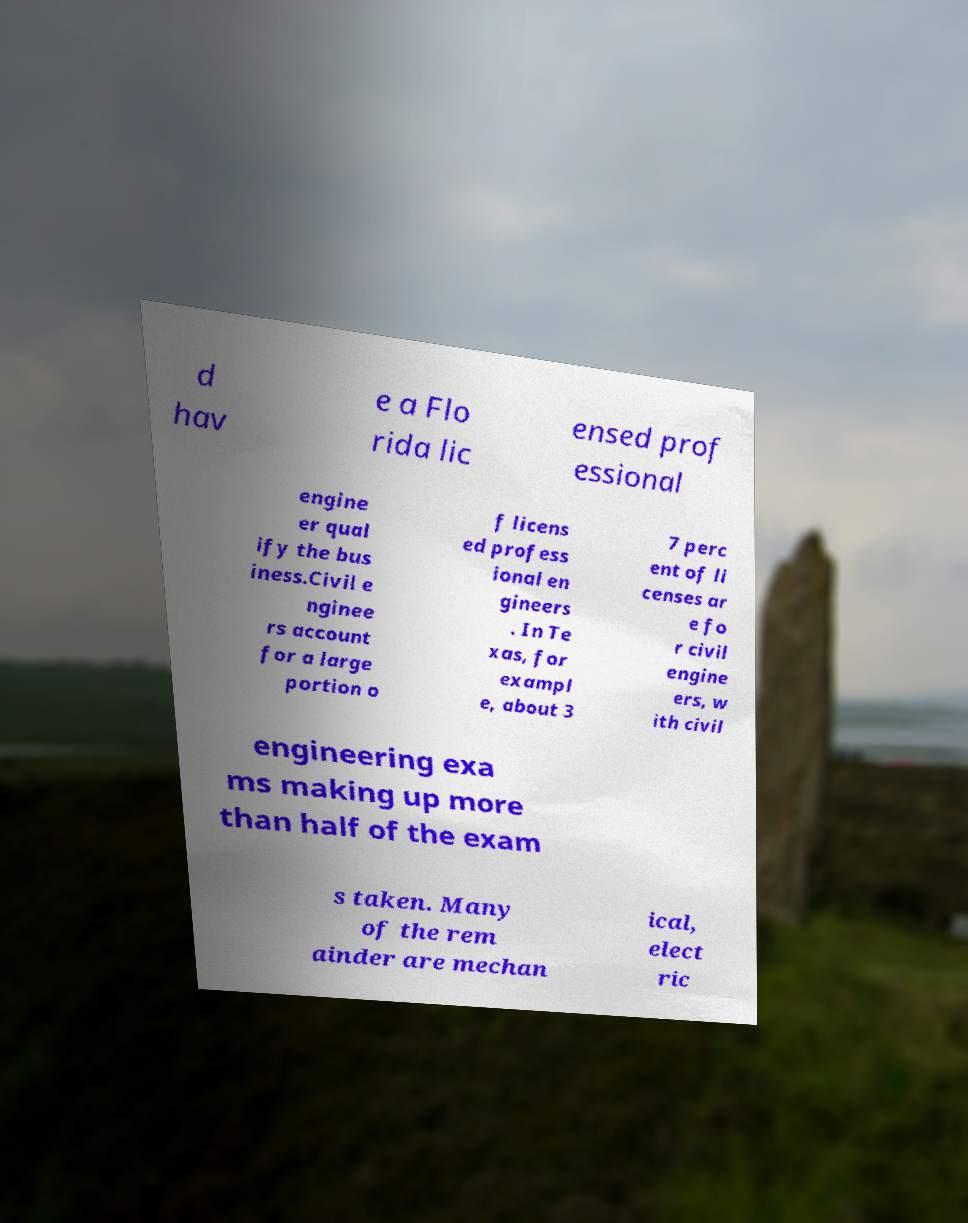What messages or text are displayed in this image? I need them in a readable, typed format. d hav e a Flo rida lic ensed prof essional engine er qual ify the bus iness.Civil e nginee rs account for a large portion o f licens ed profess ional en gineers . In Te xas, for exampl e, about 3 7 perc ent of li censes ar e fo r civil engine ers, w ith civil engineering exa ms making up more than half of the exam s taken. Many of the rem ainder are mechan ical, elect ric 